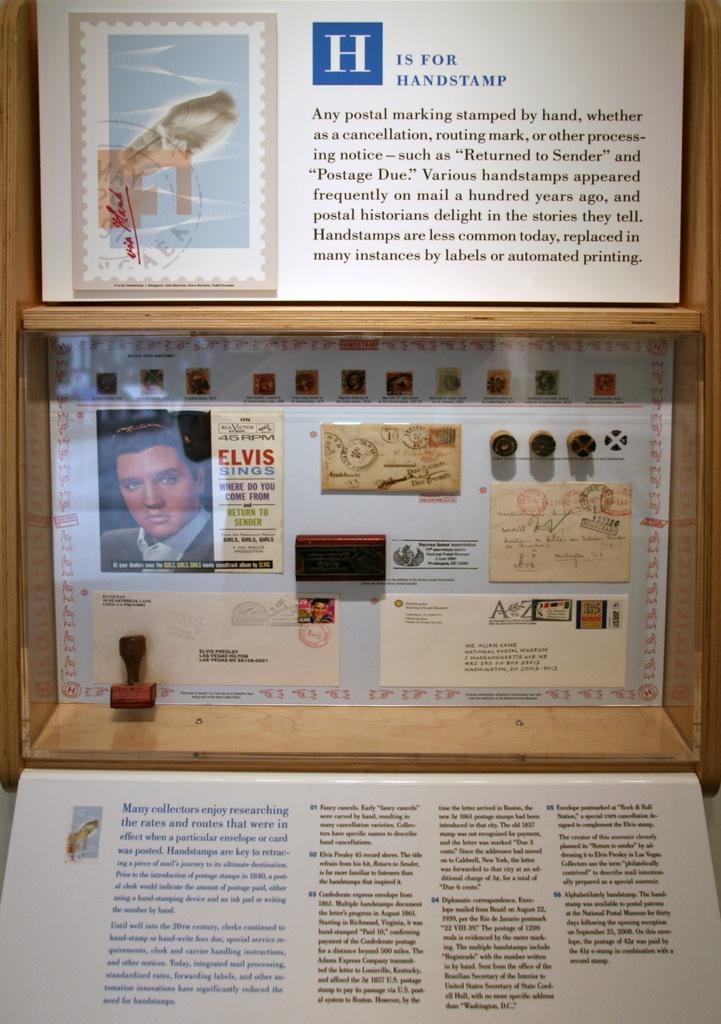<image>
Present a compact description of the photo's key features. A sign talks about postage being hand stamped. 